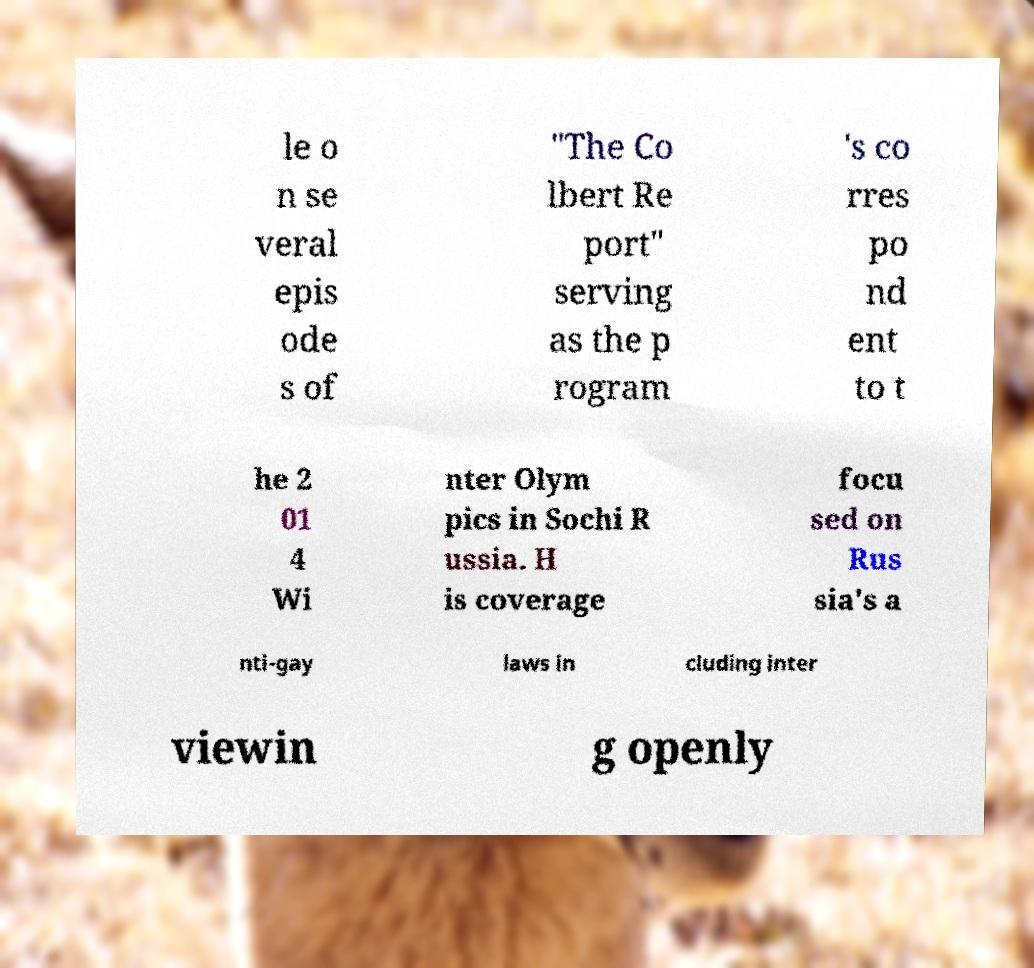I need the written content from this picture converted into text. Can you do that? le o n se veral epis ode s of "The Co lbert Re port" serving as the p rogram 's co rres po nd ent to t he 2 01 4 Wi nter Olym pics in Sochi R ussia. H is coverage focu sed on Rus sia's a nti-gay laws in cluding inter viewin g openly 